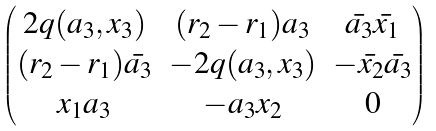<formula> <loc_0><loc_0><loc_500><loc_500>\begin{pmatrix} 2 q ( a _ { 3 } , x _ { 3 } ) & ( r _ { 2 } - r _ { 1 } ) a _ { 3 } & \bar { a _ { 3 } } \bar { x _ { 1 } } \\ ( r _ { 2 } - r _ { 1 } ) \bar { a _ { 3 } } & - 2 q ( a _ { 3 } , x _ { 3 } ) & - \bar { x _ { 2 } } \bar { a _ { 3 } } \\ x _ { 1 } a _ { 3 } & - a _ { 3 } x _ { 2 } & 0 \end{pmatrix}</formula> 